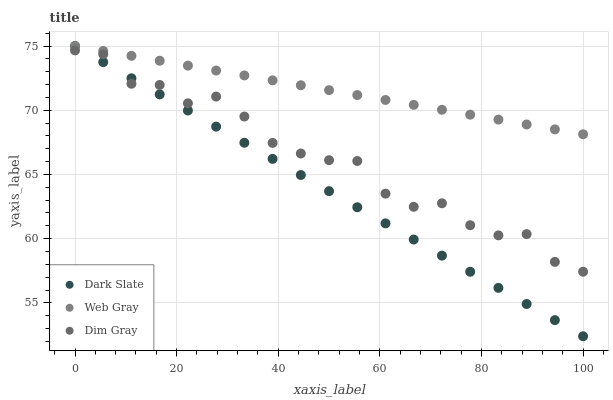Does Dark Slate have the minimum area under the curve?
Answer yes or no. Yes. Does Web Gray have the maximum area under the curve?
Answer yes or no. Yes. Does Dim Gray have the minimum area under the curve?
Answer yes or no. No. Does Dim Gray have the maximum area under the curve?
Answer yes or no. No. Is Web Gray the smoothest?
Answer yes or no. Yes. Is Dim Gray the roughest?
Answer yes or no. Yes. Is Dim Gray the smoothest?
Answer yes or no. No. Is Web Gray the roughest?
Answer yes or no. No. Does Dark Slate have the lowest value?
Answer yes or no. Yes. Does Dim Gray have the lowest value?
Answer yes or no. No. Does Web Gray have the highest value?
Answer yes or no. Yes. Does Dim Gray have the highest value?
Answer yes or no. No. Is Dim Gray less than Web Gray?
Answer yes or no. Yes. Is Web Gray greater than Dim Gray?
Answer yes or no. Yes. Does Dark Slate intersect Web Gray?
Answer yes or no. Yes. Is Dark Slate less than Web Gray?
Answer yes or no. No. Is Dark Slate greater than Web Gray?
Answer yes or no. No. Does Dim Gray intersect Web Gray?
Answer yes or no. No. 